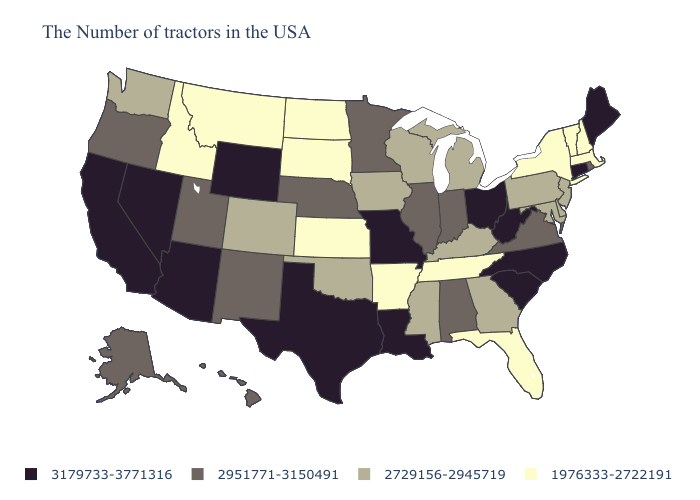Which states have the lowest value in the USA?
Quick response, please. Massachusetts, New Hampshire, Vermont, New York, Florida, Tennessee, Arkansas, Kansas, South Dakota, North Dakota, Montana, Idaho. Which states have the lowest value in the South?
Give a very brief answer. Florida, Tennessee, Arkansas. Does New Mexico have a higher value than Alaska?
Keep it brief. No. What is the value of Utah?
Write a very short answer. 2951771-3150491. Does the first symbol in the legend represent the smallest category?
Keep it brief. No. Name the states that have a value in the range 2729156-2945719?
Short answer required. New Jersey, Delaware, Maryland, Pennsylvania, Georgia, Michigan, Kentucky, Wisconsin, Mississippi, Iowa, Oklahoma, Colorado, Washington. Name the states that have a value in the range 3179733-3771316?
Write a very short answer. Maine, Connecticut, North Carolina, South Carolina, West Virginia, Ohio, Louisiana, Missouri, Texas, Wyoming, Arizona, Nevada, California. Which states have the lowest value in the USA?
Answer briefly. Massachusetts, New Hampshire, Vermont, New York, Florida, Tennessee, Arkansas, Kansas, South Dakota, North Dakota, Montana, Idaho. Does Colorado have the highest value in the USA?
Concise answer only. No. What is the value of Pennsylvania?
Keep it brief. 2729156-2945719. Name the states that have a value in the range 3179733-3771316?
Short answer required. Maine, Connecticut, North Carolina, South Carolina, West Virginia, Ohio, Louisiana, Missouri, Texas, Wyoming, Arizona, Nevada, California. What is the value of Wyoming?
Concise answer only. 3179733-3771316. What is the lowest value in the South?
Quick response, please. 1976333-2722191. What is the value of New York?
Short answer required. 1976333-2722191. 